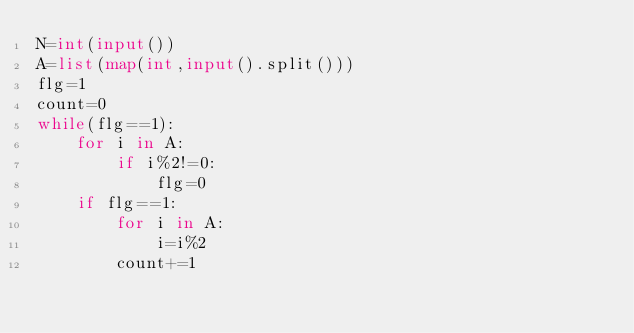Convert code to text. <code><loc_0><loc_0><loc_500><loc_500><_Python_>N=int(input())
A=list(map(int,input().split()))
flg=1
count=0
while(flg==1):
    for i in A:
        if i%2!=0:
            flg=0
    if flg==1:
        for i in A:
            i=i%2
        count+=1</code> 